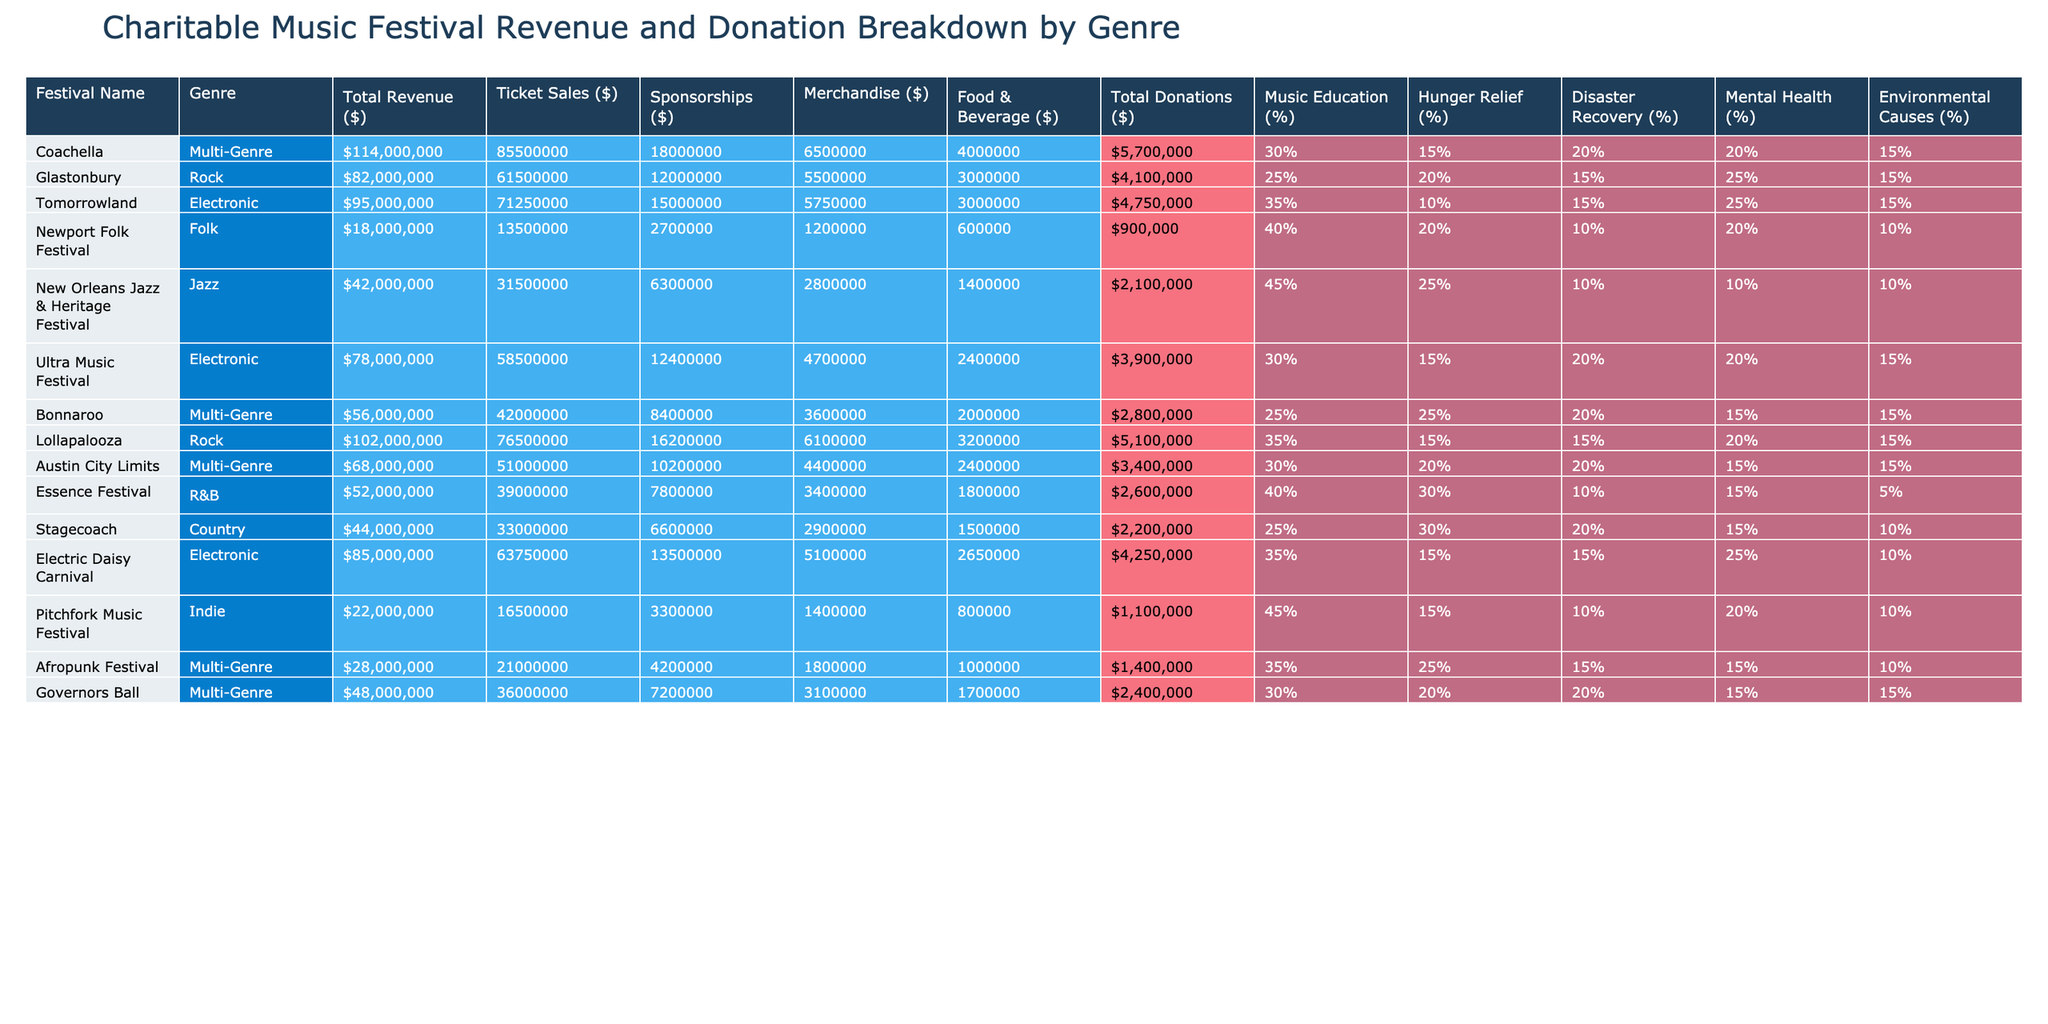What's the total revenue generated by Coachella? The total revenue for Coachella, as shown in the table, is listed under the "Total Revenue ($)" column. It is $114,000,000.
Answer: $114,000,000 Which festival generated the highest total donations? By comparing the "Total Donations ($)" for each festival, I see that New Orleans Jazz & Heritage Festival has the highest donations at $2,100,000.
Answer: $2,100,000 What percentage of total donations from Tomorrowland went to Music Education? Tomorrowland allocated 35% of its total donations to Music Education. This is directly stated in the "Music Education (%)" column.
Answer: 35% How much revenue did Lollapalooza generate from sponsorships? The revenue from sponsorships for Lollapalooza is $16,200,000, as shown in the "Sponsorships ($)" column.
Answer: $16,200,000 What is the average percentage of donations allocated to Hunger Relief across all festivals? The total percentage allocated to Hunger Relief is gathered from each festival's "Hunger Relief (%)" and averaged. The total is 30% (Coachella) + 20% (Glastonbury) + 10% (Tomorrowland) + 20% (Newport Folk Festival) + 10% (New Orleans Jazz & Heritage Festival) + 15% (Ultra Music Festival) + 25% (Bonnaroo) + 15% (Lollapalooza) + 30% (Austin City Limits) + 10% (Essence Festival) + 20% (Stagecoach) + 15% (Electric Daisy Carnival) + 15% (Pitchfork Music Festival) + 15% (Afropunk Festival) + 20% (Governors Ball) = 18% / 15 = 16.33%, rounded to approximately 16%.
Answer: 16% Does the Newport Folk Festival have a higher percentage allocated to Mental Health than Tomorrowland? Newport Folk Festival allocates 20% to Mental Health, while Tomorrowland allocates 25%. Since 20% is less than 25%, the statement is false.
Answer: No Which genre has the highest average revenue from ticket sales? To find the genre with the highest average ticket sales revenue, sum the ticket sales for each genre and divide by the number of festivals in that genre. The Multi-Genre average is ($85,500,000 + $56,000,000 + $68,000,000 + $48,000,000) / 4 = $64,625,000; Rock's average is ($61,500,000 + $76,500,000) / 2 = $69,000,000; Electronic's average is ($71,250,000 + $58,500,000) / 2 = $64,875,000. The average for Multi-Genre is lower, thus, Rock has the highest average ticket revenue.
Answer: Rock How much more revenue did ticket sales generate at Coachella compared to the Newport Folk Festival? Comparing ticket sales: Coachella generated $85,500,000, and Newport Folk Festival generated $13,500,000. The difference is calculated as $85,500,000 - $13,500,000 = $72,000,000.
Answer: $72,000,000 What genre does the Electric Daisy Carnival belong to? The Electric Daisy Carnival belongs to the Electronic genre, as indicated in the "Genre" column of the table.
Answer: Electronic What percentage of total donations for the Afropunk Festival is allocated to Environmental Causes? The table indicates that 10% of the total donations from the Afropunk Festival are designated for Environmental Causes, as detailed in the corresponding column.
Answer: 10% What is the total revenue across all festivals combined? To find the total revenue, sum the total revenue values from all festivals: $114,000,000 + $82,000,000 + $95,000,000 + $18,000,000 + $42,000,000 + $78,000,000 + $56,000,000 + $102,000,000 + $68,000,000 + $52,000,000 + $44,000,000 + $85,000,000 + $22,000,000 + $28,000,000 + $48,000,000 = $1,167,000,000.
Answer: $1,167,000,000 